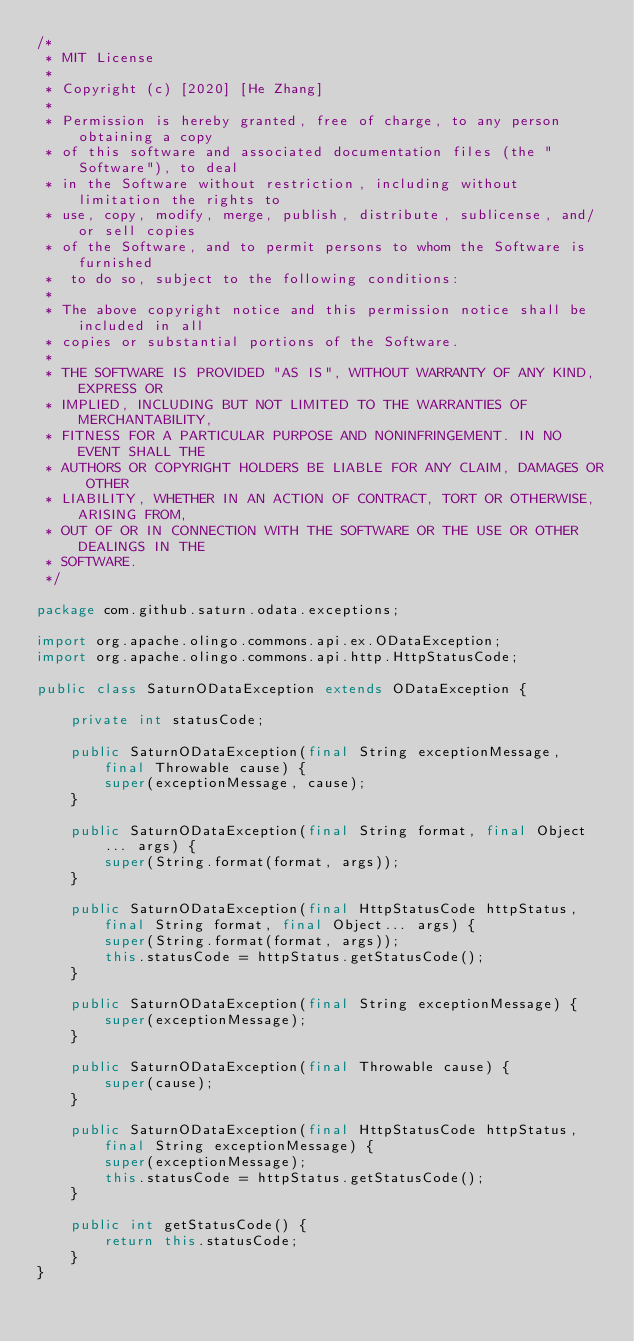<code> <loc_0><loc_0><loc_500><loc_500><_Java_>/*
 * MIT License
 *
 * Copyright (c) [2020] [He Zhang]
 *
 * Permission is hereby granted, free of charge, to any person obtaining a copy
 * of this software and associated documentation files (the "Software"), to deal
 * in the Software without restriction, including without limitation the rights to
 * use, copy, modify, merge, publish, distribute, sublicense, and/or sell copies
 * of the Software, and to permit persons to whom the Software is furnished
 *  to do so, subject to the following conditions:
 *
 * The above copyright notice and this permission notice shall be included in all
 * copies or substantial portions of the Software.
 *
 * THE SOFTWARE IS PROVIDED "AS IS", WITHOUT WARRANTY OF ANY KIND, EXPRESS OR
 * IMPLIED, INCLUDING BUT NOT LIMITED TO THE WARRANTIES OF MERCHANTABILITY,
 * FITNESS FOR A PARTICULAR PURPOSE AND NONINFRINGEMENT. IN NO EVENT SHALL THE
 * AUTHORS OR COPYRIGHT HOLDERS BE LIABLE FOR ANY CLAIM, DAMAGES OR OTHER
 * LIABILITY, WHETHER IN AN ACTION OF CONTRACT, TORT OR OTHERWISE, ARISING FROM,
 * OUT OF OR IN CONNECTION WITH THE SOFTWARE OR THE USE OR OTHER DEALINGS IN THE
 * SOFTWARE.
 */

package com.github.saturn.odata.exceptions;

import org.apache.olingo.commons.api.ex.ODataException;
import org.apache.olingo.commons.api.http.HttpStatusCode;

public class SaturnODataException extends ODataException {

    private int statusCode;

    public SaturnODataException(final String exceptionMessage, final Throwable cause) {
        super(exceptionMessage, cause);
    }

    public SaturnODataException(final String format, final Object... args) {
        super(String.format(format, args));
    }

    public SaturnODataException(final HttpStatusCode httpStatus, final String format, final Object... args) {
        super(String.format(format, args));
        this.statusCode = httpStatus.getStatusCode();
    }

    public SaturnODataException(final String exceptionMessage) {
        super(exceptionMessage);
    }

    public SaturnODataException(final Throwable cause) {
        super(cause);
    }

    public SaturnODataException(final HttpStatusCode httpStatus, final String exceptionMessage) {
        super(exceptionMessage);
        this.statusCode = httpStatus.getStatusCode();
    }

    public int getStatusCode() {
        return this.statusCode;
    }
}
</code> 